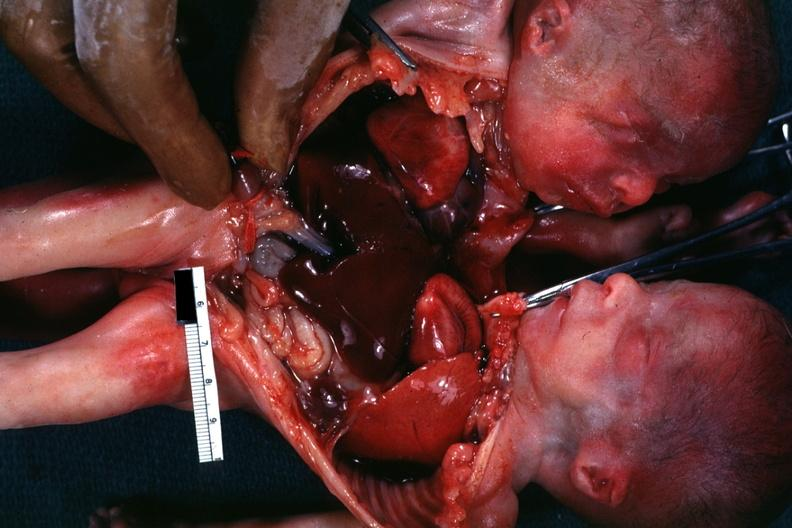what does this image show?
Answer the question using a single word or phrase. Joined anterior chest and abdomen 